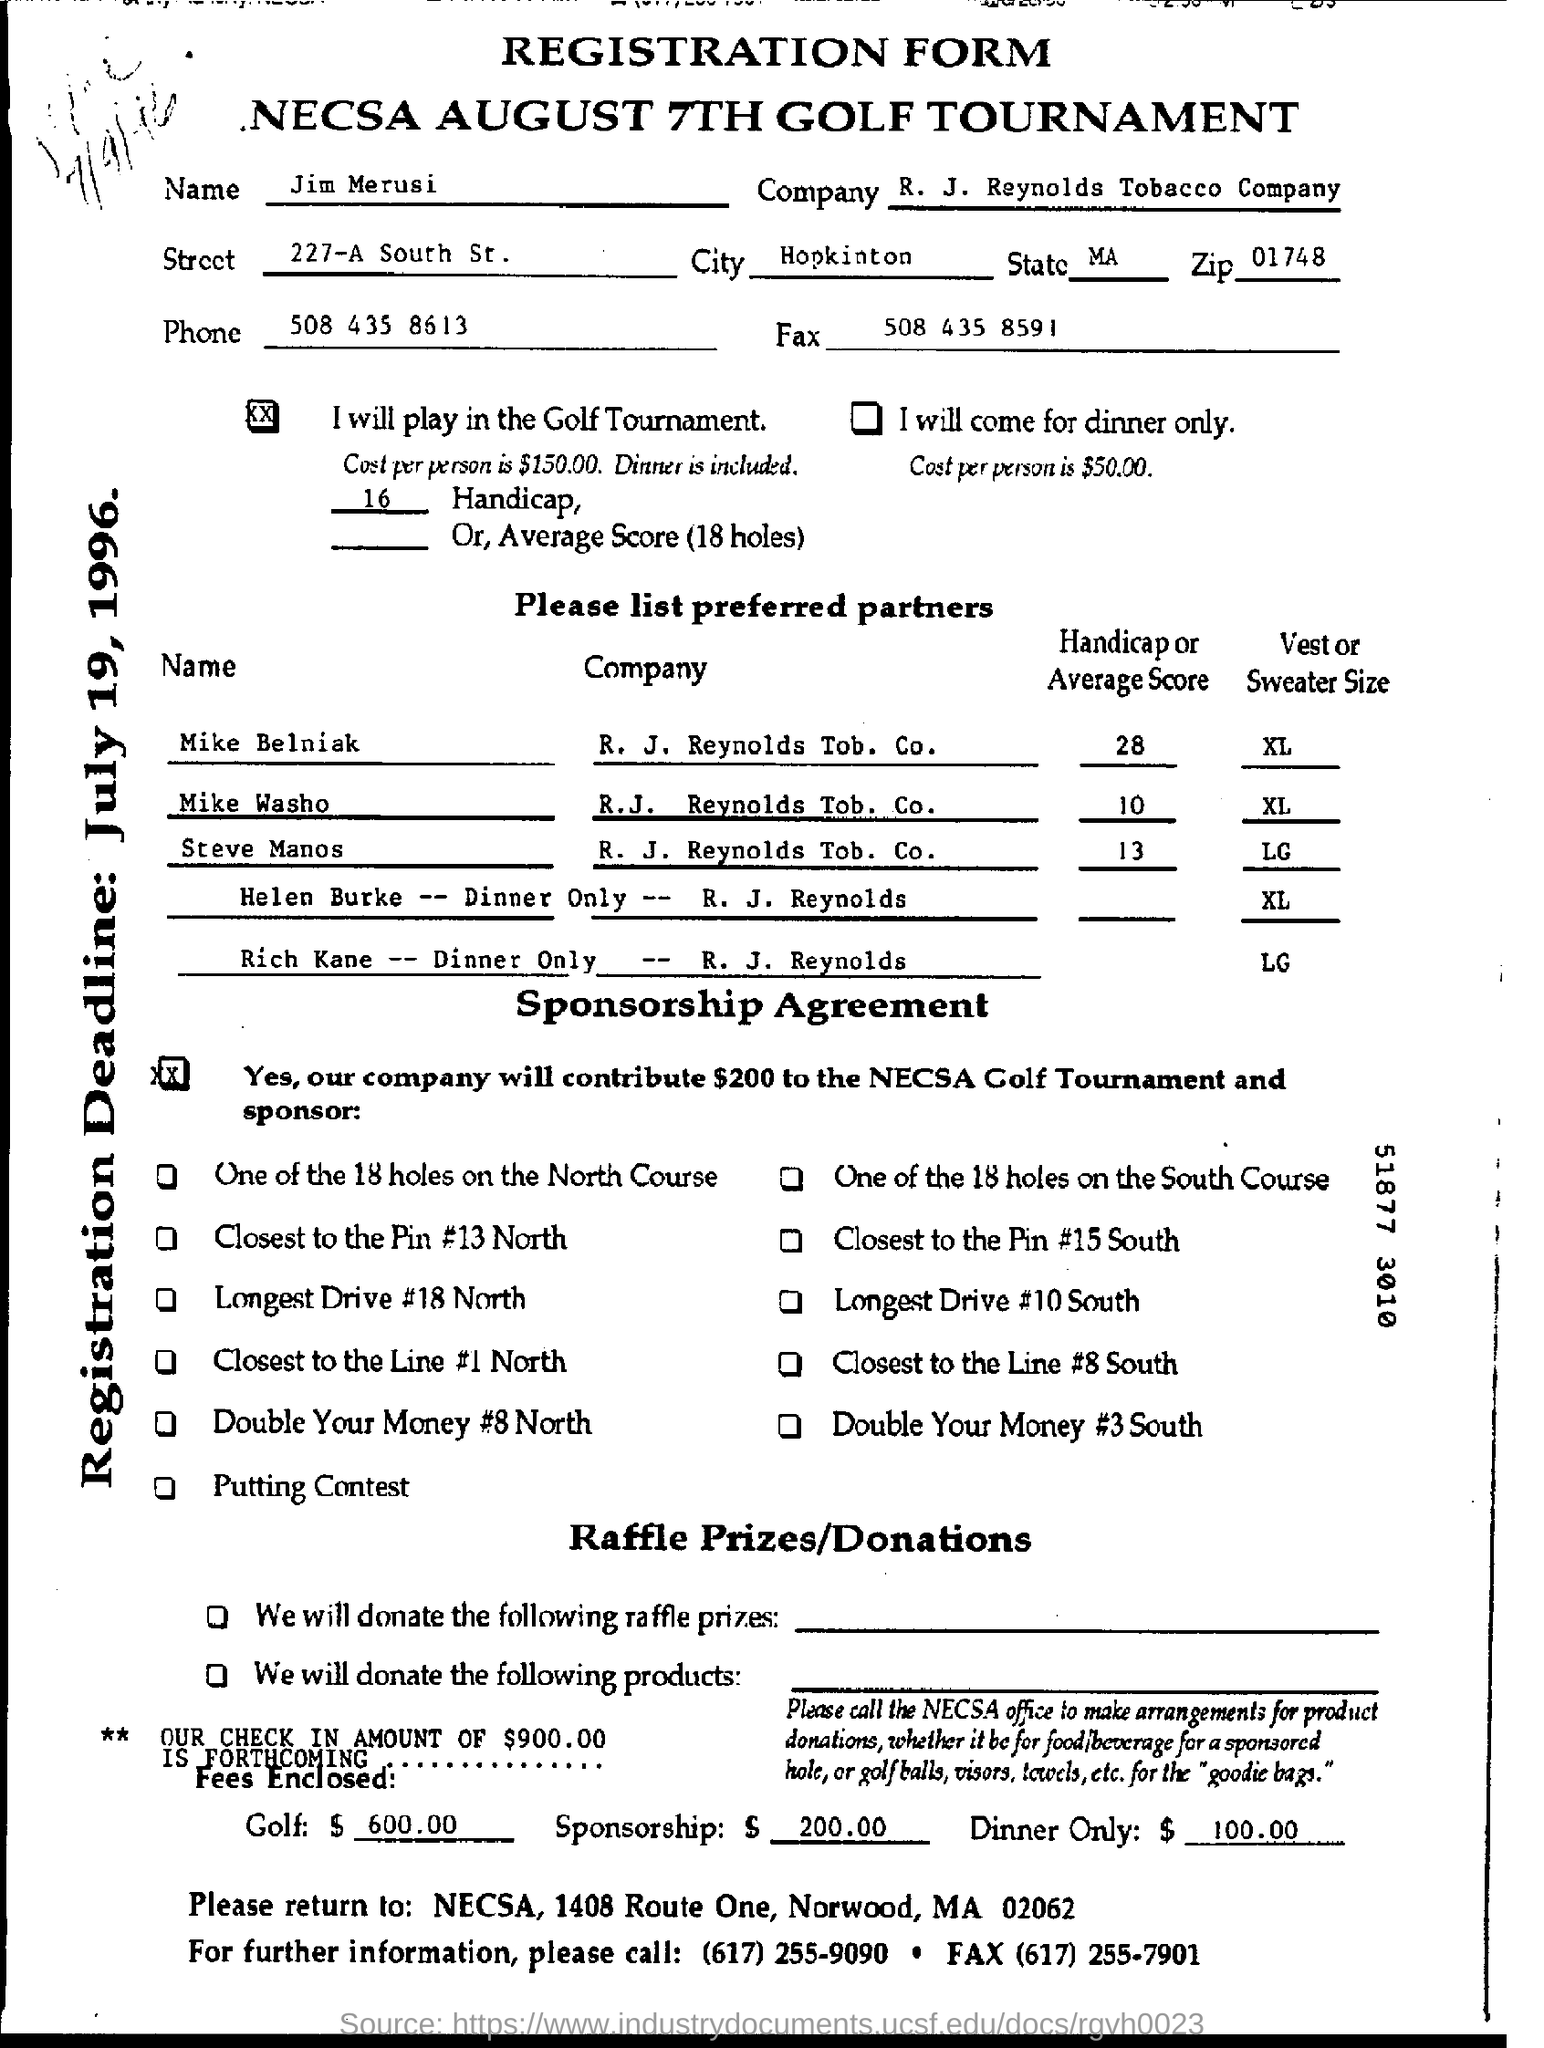List a handful of essential elements in this visual. I am looking for the phone number of Jim Merusi, which is 508 435 8613. The zip code is 01748. I do not know the fax number. It is 508 435 8591. The NECSA August 7th Golf Tournament is the name of the tournament. 